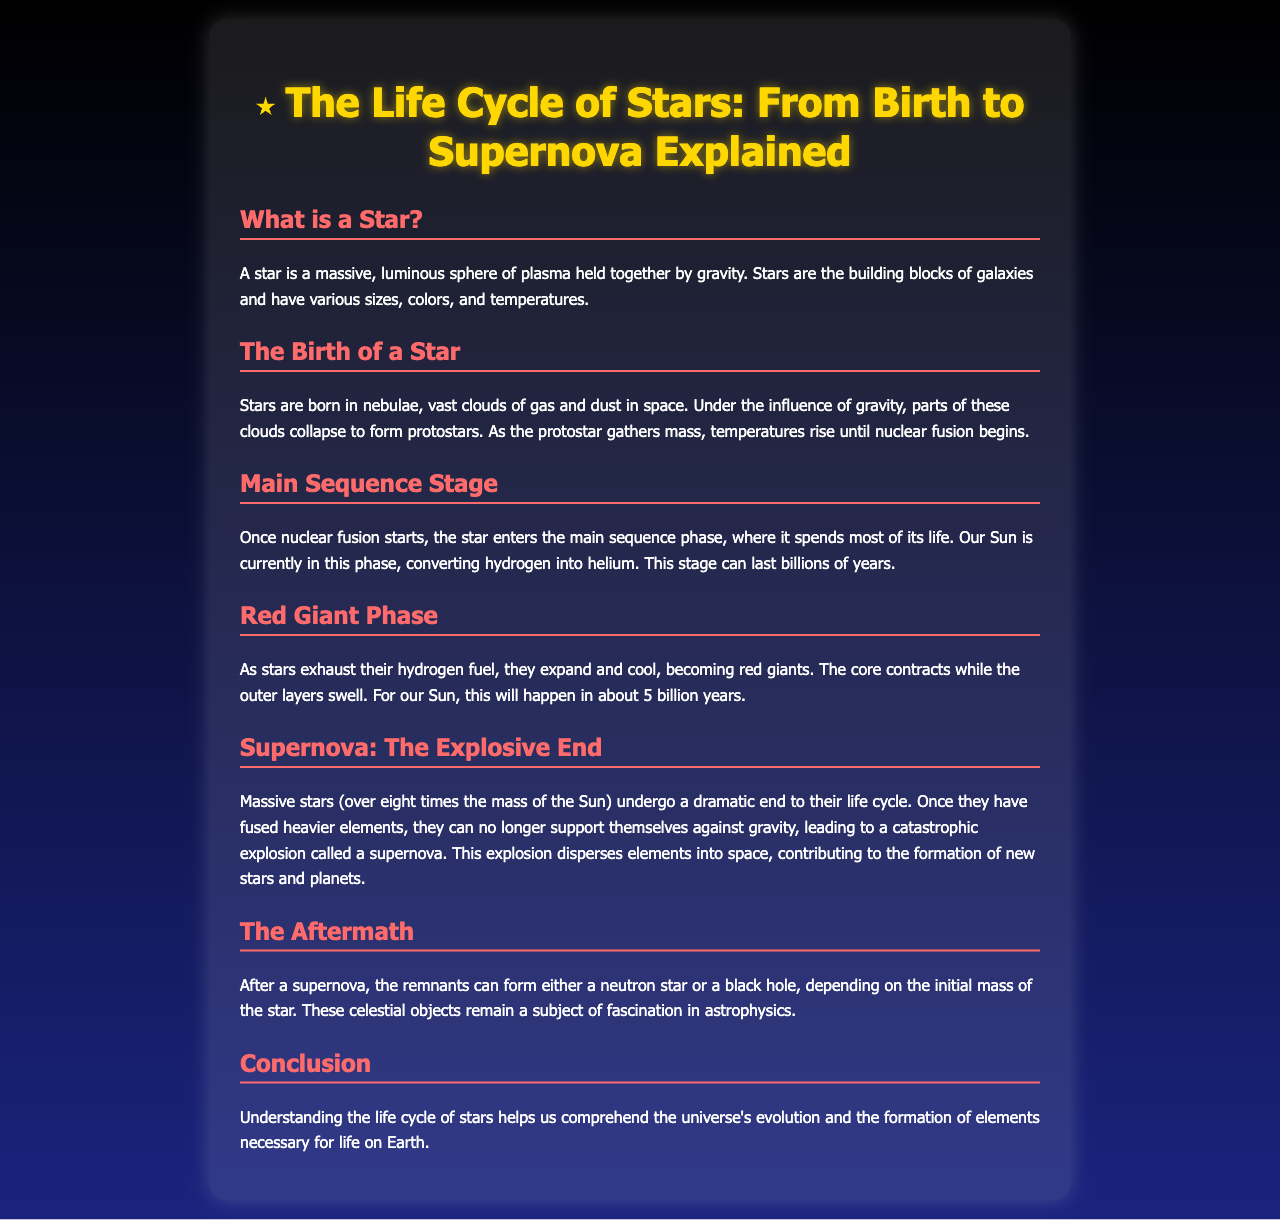What is a star? A star is a massive, luminous sphere of plasma held together by gravity.
Answer: A massive, luminous sphere of plasma What is the main sequence phase? The main sequence phase is when the star spends most of its life converting hydrogen into helium.
Answer: Converting hydrogen into helium How long can the main sequence stage last? The document states that this stage can last billions of years.
Answer: Billions of years What happens to stars in the red giant phase? Stars expand and cool, becoming red giants as they exhaust their hydrogen fuel.
Answer: They expand and cool What is a supernova? A supernova is a catastrophic explosion that occurs at the end of the life cycle of massive stars.
Answer: A catastrophic explosion What can form after a supernova? The remnants can form either a neutron star or a black hole.
Answer: Neutron star or black hole Why is understanding the life cycle of stars important? It helps us comprehend the universe's evolution and the formation of elements necessary for life.
Answer: Universe's evolution and element formation In what type of regions are stars born? Stars are born in nebulae.
Answer: Nebulae How long until our Sun becomes a red giant? It will happen in about 5 billion years.
Answer: About 5 billion years 